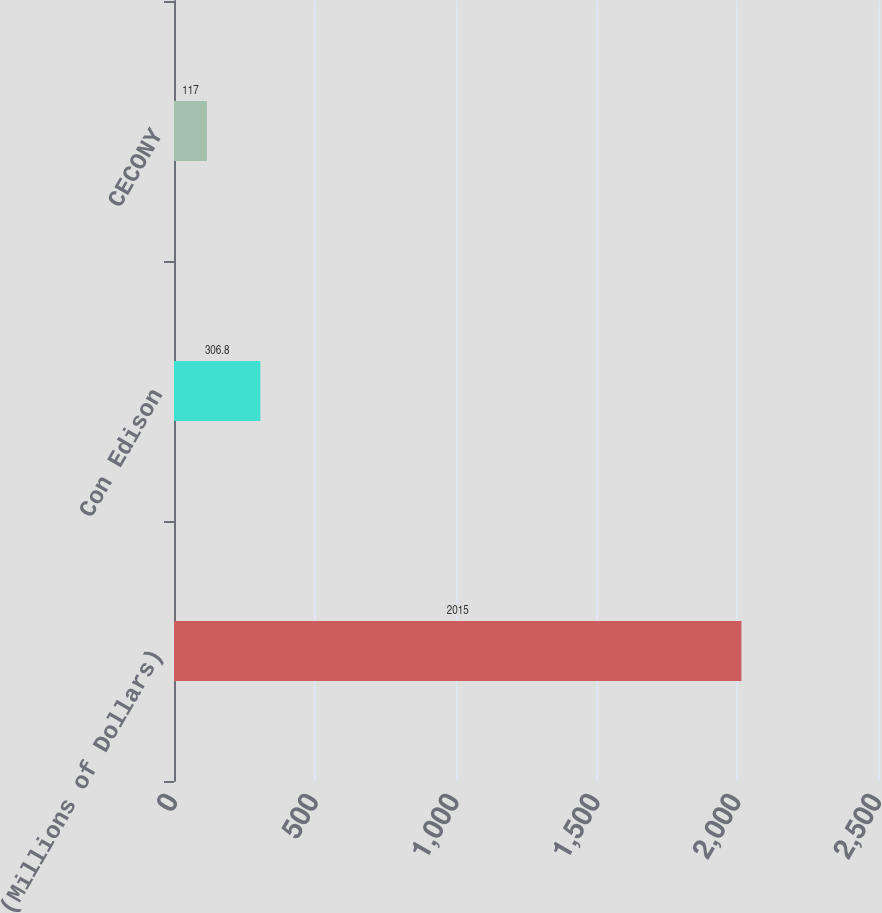<chart> <loc_0><loc_0><loc_500><loc_500><bar_chart><fcel>(Millions of Dollars)<fcel>Con Edison<fcel>CECONY<nl><fcel>2015<fcel>306.8<fcel>117<nl></chart> 